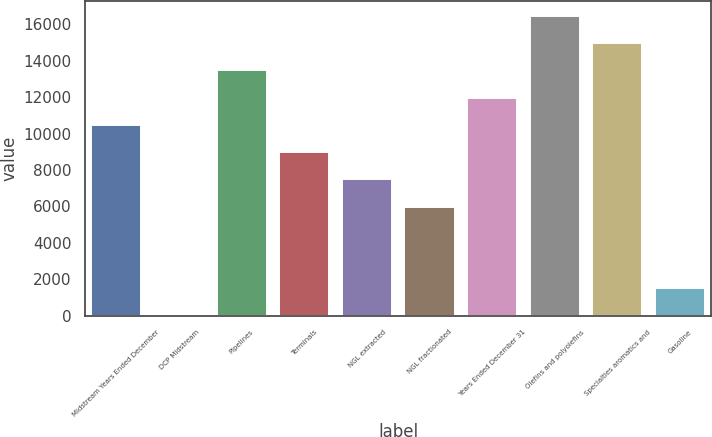Convert chart. <chart><loc_0><loc_0><loc_500><loc_500><bar_chart><fcel>Midstream Years Ended December<fcel>DCP Midstream<fcel>Pipelines<fcel>Terminals<fcel>NGL extracted<fcel>NGL fractionated<fcel>Years Ended December 31<fcel>Olefins and polyolefins<fcel>Specialties aromatics and<fcel>Gasoline<nl><fcel>10477.2<fcel>0.82<fcel>13470.4<fcel>8980.54<fcel>7483.92<fcel>5987.3<fcel>11973.8<fcel>16463.6<fcel>14967<fcel>1497.44<nl></chart> 